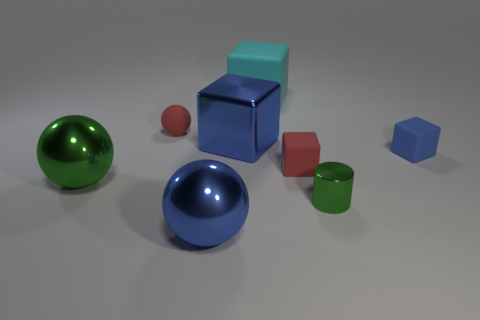Are there an equal number of tiny blue blocks to the left of the large blue block and blue spheres?
Your response must be concise. No. Is there anything else that has the same size as the blue rubber cube?
Give a very brief answer. Yes. What number of things are big cyan rubber objects or brown rubber things?
Give a very brief answer. 1. What shape is the large green thing that is the same material as the tiny green object?
Provide a short and direct response. Sphere. How big is the red rubber object right of the tiny red object that is left of the blue metal sphere?
Your response must be concise. Small. What number of big things are red cylinders or red matte spheres?
Make the answer very short. 0. What number of other objects are there of the same color as the metallic cylinder?
Provide a succinct answer. 1. There is a rubber thing to the left of the large blue metallic sphere; is it the same size as the red object that is on the right side of the cyan block?
Make the answer very short. Yes. Are the small blue cube and the big blue thing in front of the big blue cube made of the same material?
Your answer should be very brief. No. Are there more green objects that are behind the green metallic cylinder than small cylinders behind the red block?
Provide a short and direct response. Yes. 